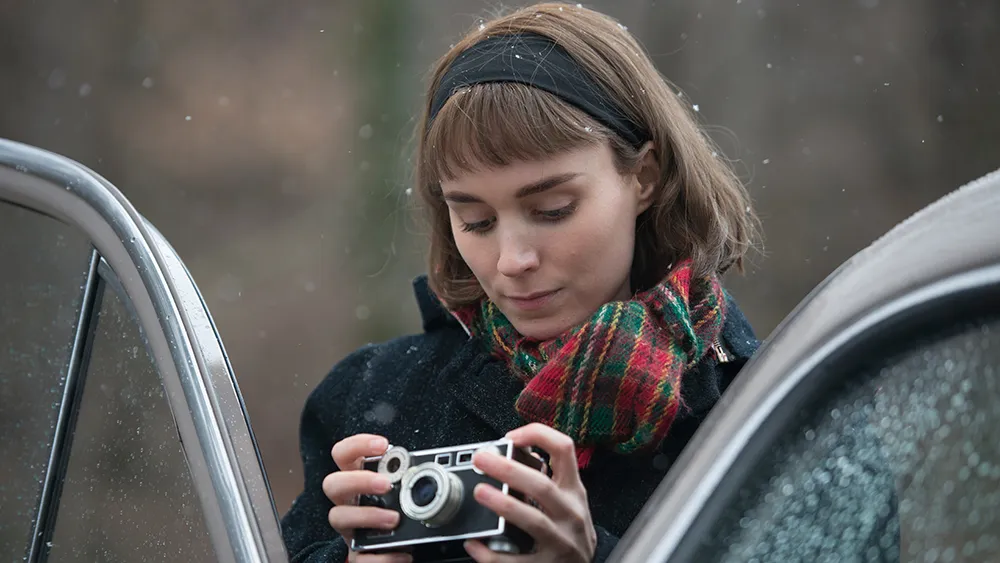Imagine a story about her trip through the forest. On a chilly autumn morning, she embarked on a journey through the forest with her trusty camera. Each click captured hidden wonders – a squirrel scrambling up a tree, the intricate design of fallen leaves, and the shimmering dew on spider webs. Despite the solitude, she felt an unparalleled connection with nature, each photograph a token of the peaceful coexistence between her and the woodland creatures. The conversation between the crunching leaves beneath her boots and the soft pitter-patter of rain set the soundtrack for an unforgettable adventure. What kind of character do you think she is? She appears to be an introspective and observant individual, with a deep appreciation for the beauty found in life's quiet moments. Her choice of a vintage camera over modern digital alternatives suggests a preference for the tactile and authentic, perhaps valuing the process of photography as much as the end result. The vibrant scarf hints at a personality that embraces color and warmth, juxtaposing her otherwise understated attire, likely a symbol of her unique flair and passionate spirit. Write a detailed journal entry she might write for that day. October 15th,

Today was a day that sang softly to my soul. The forest, veiled in a delicate mist and adorned with the first whispers of snow, became my sanctuary. Armed with my beloved old camera, I took to the trails less traveled, eager to uncover the secrets hidden amongst the trees. Each breath of cool air invigorated me, and with every step, I felt more attuned to the symphony of nature. I stumbled upon a family of deer grazing silently, capturing their grace with the perfect click. The rain-kissed foliage shimmered around me, a testament to the gentle embrace of the dawn's drizzle.

I paused often, not just to photograph, but to exist in those moments – to feel the weight of the earth beneath me, to hear the whispers of the wind through the barren branches. The car, too, offered respite, its cool metal juxtaposed against the warm beating of my heart. As the day drew on and the woodland began to blur into twilight, I returned home with a heart full of quiet joy and a camera full of stories. Each photo, a chapter, a snapshot of the forest's silent poetry and my solitary dialogue with it.

Until tomorrow, 